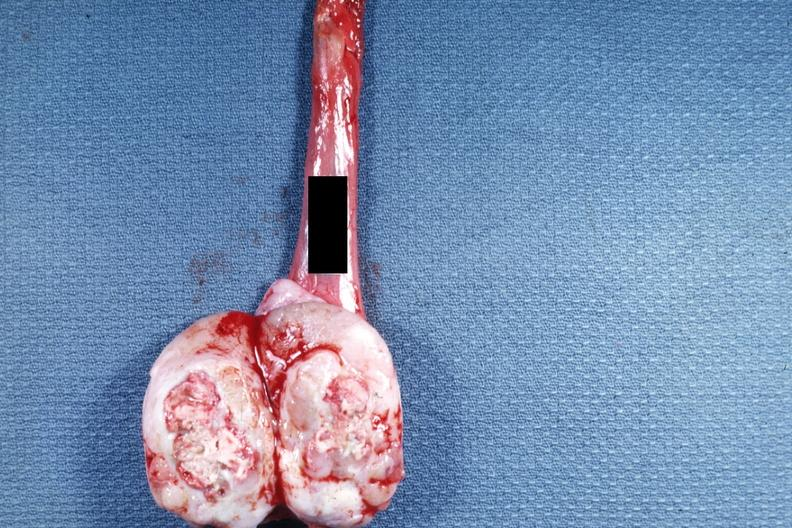what is present?
Answer the question using a single word or phrase. Seminoma 